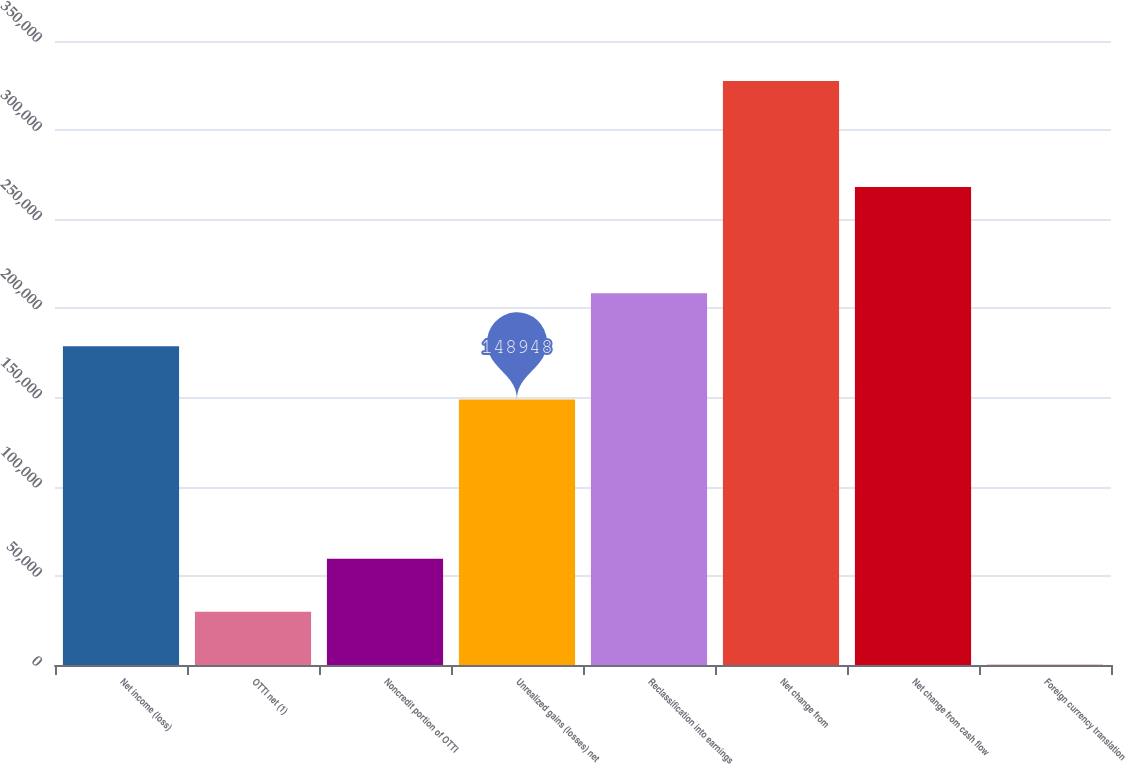Convert chart to OTSL. <chart><loc_0><loc_0><loc_500><loc_500><bar_chart><fcel>Net income (loss)<fcel>OTTI net (1)<fcel>Noncredit portion of OTTI<fcel>Unrealized gains (losses) net<fcel>Reclassification into earnings<fcel>Net change from<fcel>Net change from cash flow<fcel>Foreign currency translation<nl><fcel>178723<fcel>29849.6<fcel>59624.2<fcel>148948<fcel>208497<fcel>327596<fcel>268046<fcel>75<nl></chart> 